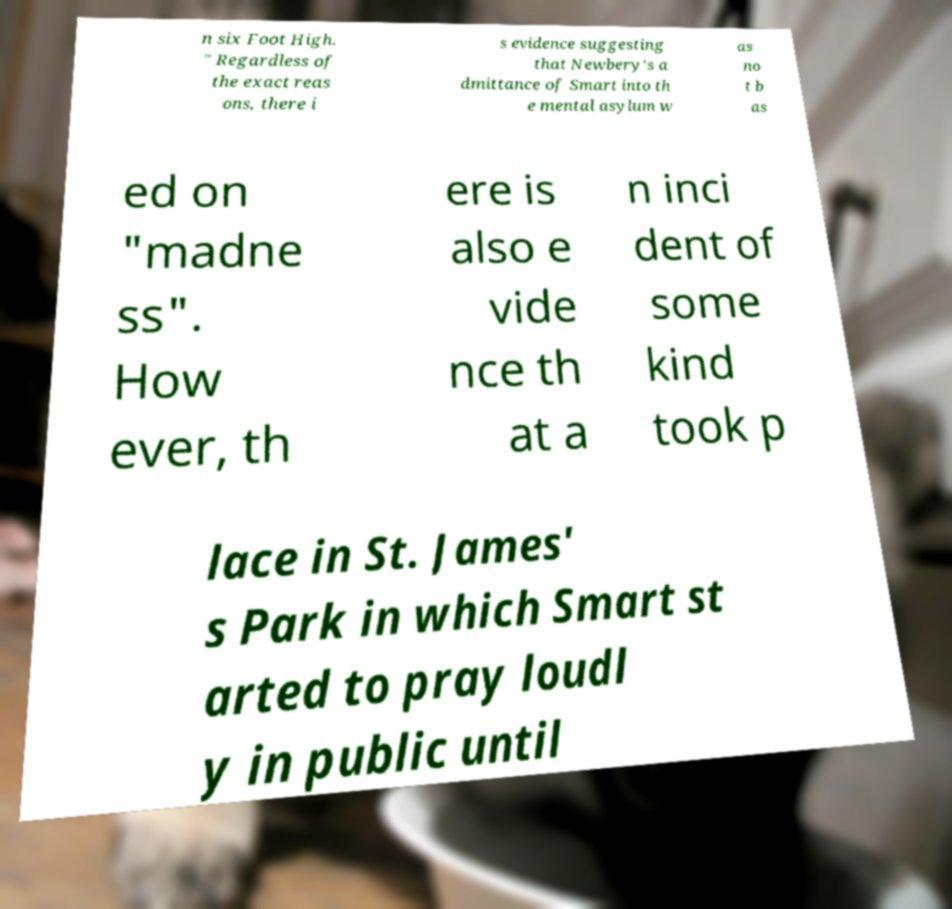For documentation purposes, I need the text within this image transcribed. Could you provide that? n six Foot High. " Regardless of the exact reas ons, there i s evidence suggesting that Newbery's a dmittance of Smart into th e mental asylum w as no t b as ed on "madne ss". How ever, th ere is also e vide nce th at a n inci dent of some kind took p lace in St. James' s Park in which Smart st arted to pray loudl y in public until 